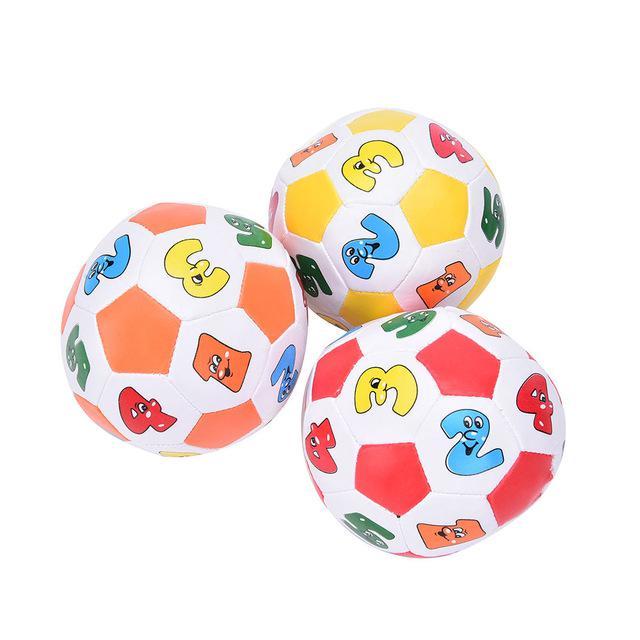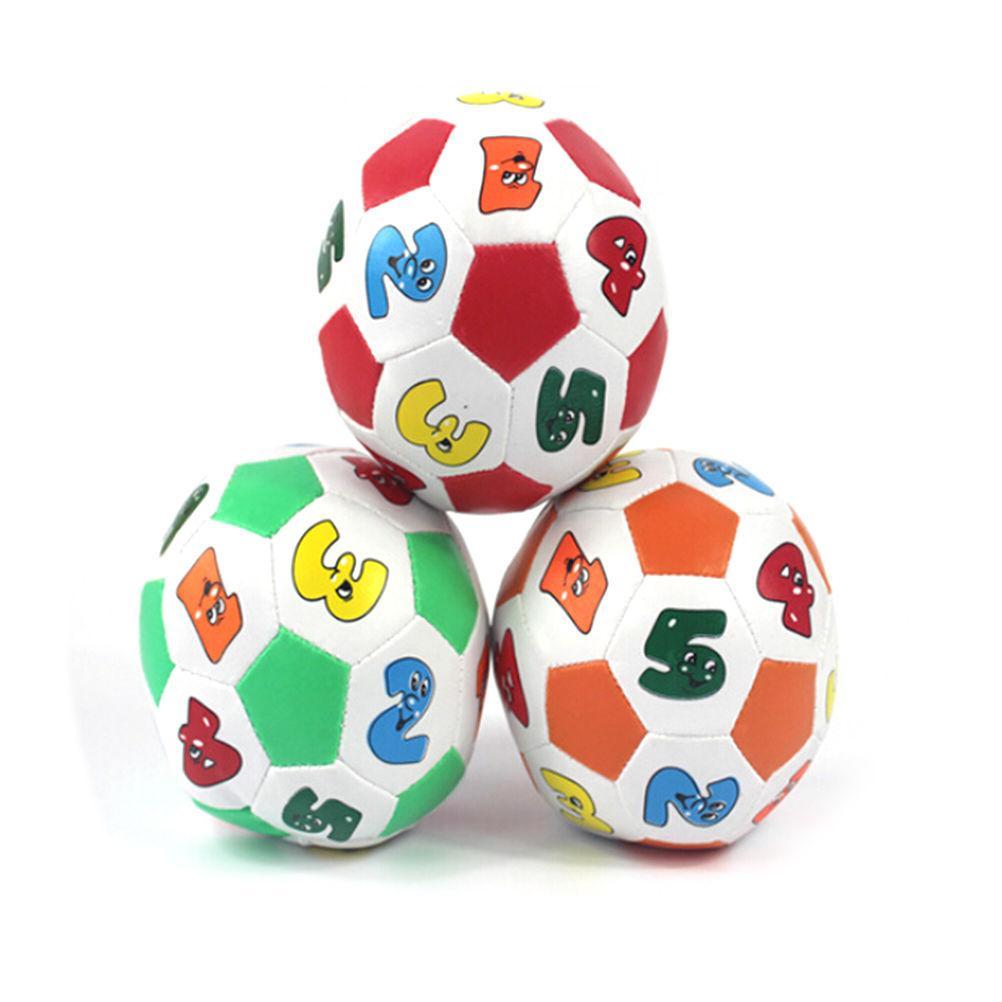The first image is the image on the left, the second image is the image on the right. Evaluate the accuracy of this statement regarding the images: "There are more than 3 balls painted like soccer balls, and there are no numbers on any of them.". Is it true? Answer yes or no. No. The first image is the image on the left, the second image is the image on the right. Considering the images on both sides, is "Two of the soccer balls are pink." valid? Answer yes or no. No. 